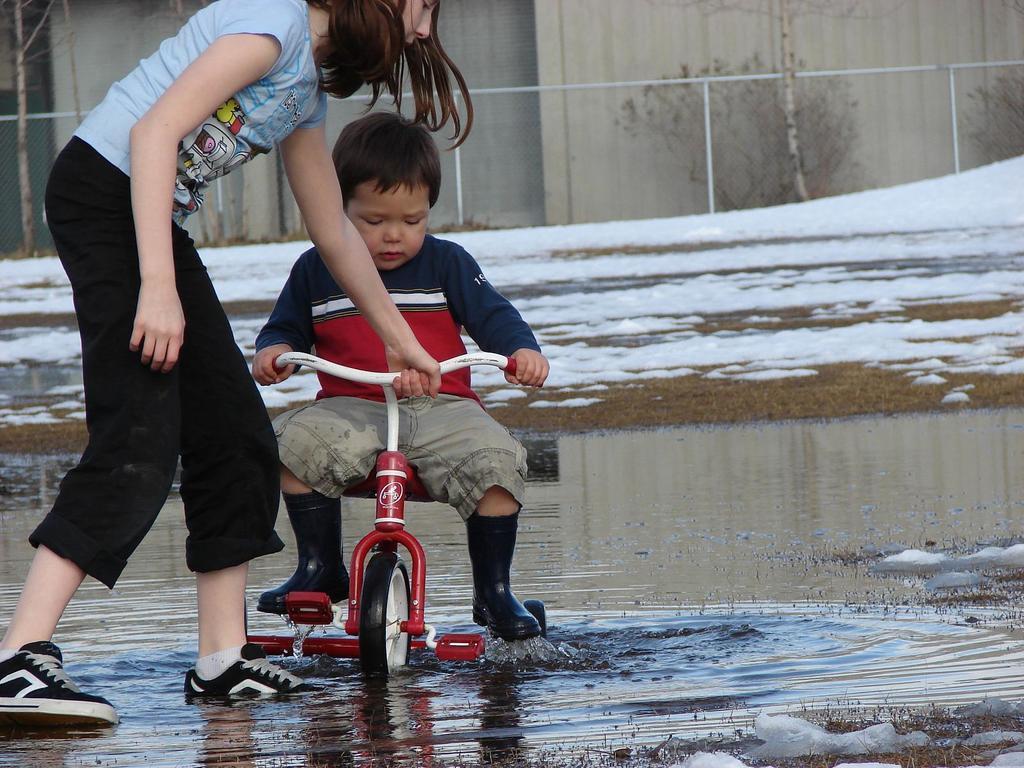Could you give a brief overview of what you see in this image? In the middle there is a boy he is riding bicycle he wear t shirt ,trouser and shoes. On the left there is a woman she wear t shirt , trouser and shoes ,her hair is short. In the background there is ice, water ,plant,wall and window. 